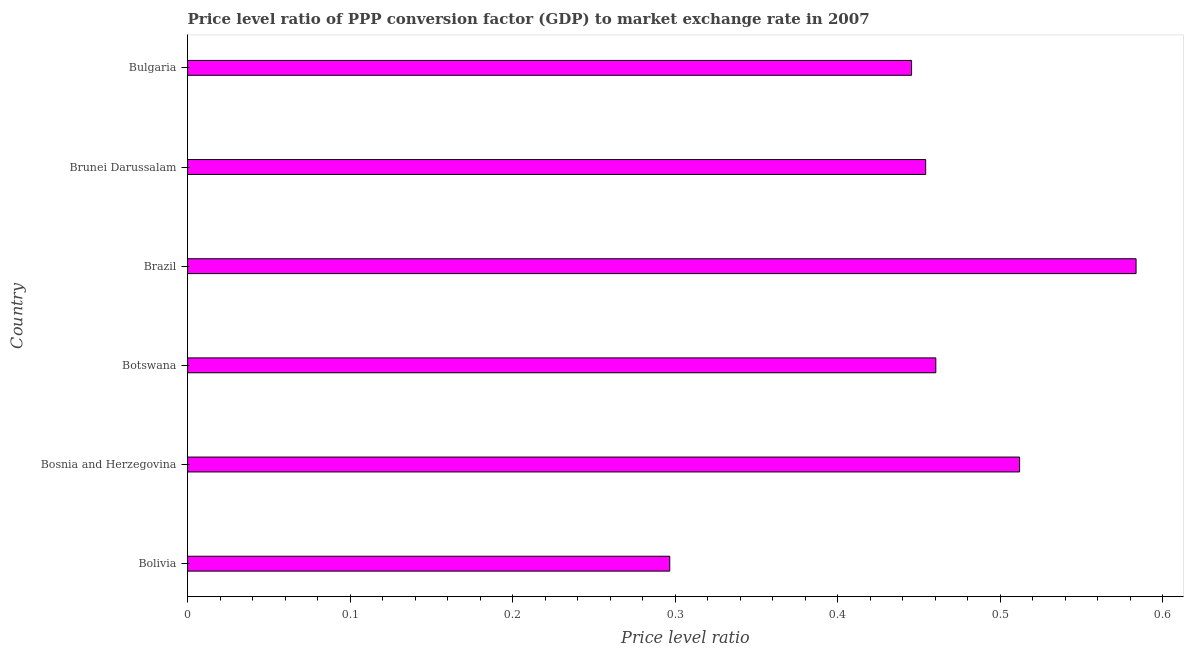What is the title of the graph?
Your answer should be compact. Price level ratio of PPP conversion factor (GDP) to market exchange rate in 2007. What is the label or title of the X-axis?
Ensure brevity in your answer.  Price level ratio. What is the price level ratio in Bosnia and Herzegovina?
Provide a short and direct response. 0.51. Across all countries, what is the maximum price level ratio?
Ensure brevity in your answer.  0.58. Across all countries, what is the minimum price level ratio?
Keep it short and to the point. 0.3. In which country was the price level ratio minimum?
Give a very brief answer. Bolivia. What is the sum of the price level ratio?
Give a very brief answer. 2.75. What is the difference between the price level ratio in Bolivia and Brazil?
Provide a short and direct response. -0.29. What is the average price level ratio per country?
Your response must be concise. 0.46. What is the median price level ratio?
Your answer should be compact. 0.46. In how many countries, is the price level ratio greater than 0.04 ?
Your answer should be very brief. 6. What is the ratio of the price level ratio in Bosnia and Herzegovina to that in Brunei Darussalam?
Your answer should be compact. 1.13. Is the price level ratio in Bosnia and Herzegovina less than that in Bulgaria?
Make the answer very short. No. What is the difference between the highest and the second highest price level ratio?
Your response must be concise. 0.07. Is the sum of the price level ratio in Bosnia and Herzegovina and Brunei Darussalam greater than the maximum price level ratio across all countries?
Provide a succinct answer. Yes. What is the difference between the highest and the lowest price level ratio?
Make the answer very short. 0.29. In how many countries, is the price level ratio greater than the average price level ratio taken over all countries?
Your answer should be very brief. 3. Are all the bars in the graph horizontal?
Offer a very short reply. Yes. Are the values on the major ticks of X-axis written in scientific E-notation?
Give a very brief answer. No. What is the Price level ratio in Bolivia?
Offer a terse response. 0.3. What is the Price level ratio of Bosnia and Herzegovina?
Make the answer very short. 0.51. What is the Price level ratio in Botswana?
Provide a succinct answer. 0.46. What is the Price level ratio of Brazil?
Offer a terse response. 0.58. What is the Price level ratio of Brunei Darussalam?
Your response must be concise. 0.45. What is the Price level ratio in Bulgaria?
Ensure brevity in your answer.  0.45. What is the difference between the Price level ratio in Bolivia and Bosnia and Herzegovina?
Offer a very short reply. -0.22. What is the difference between the Price level ratio in Bolivia and Botswana?
Provide a succinct answer. -0.16. What is the difference between the Price level ratio in Bolivia and Brazil?
Give a very brief answer. -0.29. What is the difference between the Price level ratio in Bolivia and Brunei Darussalam?
Ensure brevity in your answer.  -0.16. What is the difference between the Price level ratio in Bolivia and Bulgaria?
Give a very brief answer. -0.15. What is the difference between the Price level ratio in Bosnia and Herzegovina and Botswana?
Keep it short and to the point. 0.05. What is the difference between the Price level ratio in Bosnia and Herzegovina and Brazil?
Provide a succinct answer. -0.07. What is the difference between the Price level ratio in Bosnia and Herzegovina and Brunei Darussalam?
Ensure brevity in your answer.  0.06. What is the difference between the Price level ratio in Bosnia and Herzegovina and Bulgaria?
Your answer should be compact. 0.07. What is the difference between the Price level ratio in Botswana and Brazil?
Give a very brief answer. -0.12. What is the difference between the Price level ratio in Botswana and Brunei Darussalam?
Keep it short and to the point. 0.01. What is the difference between the Price level ratio in Botswana and Bulgaria?
Make the answer very short. 0.01. What is the difference between the Price level ratio in Brazil and Brunei Darussalam?
Provide a succinct answer. 0.13. What is the difference between the Price level ratio in Brazil and Bulgaria?
Ensure brevity in your answer.  0.14. What is the difference between the Price level ratio in Brunei Darussalam and Bulgaria?
Your answer should be compact. 0.01. What is the ratio of the Price level ratio in Bolivia to that in Bosnia and Herzegovina?
Make the answer very short. 0.58. What is the ratio of the Price level ratio in Bolivia to that in Botswana?
Provide a short and direct response. 0.64. What is the ratio of the Price level ratio in Bolivia to that in Brazil?
Provide a succinct answer. 0.51. What is the ratio of the Price level ratio in Bolivia to that in Brunei Darussalam?
Your answer should be very brief. 0.65. What is the ratio of the Price level ratio in Bolivia to that in Bulgaria?
Offer a terse response. 0.67. What is the ratio of the Price level ratio in Bosnia and Herzegovina to that in Botswana?
Give a very brief answer. 1.11. What is the ratio of the Price level ratio in Bosnia and Herzegovina to that in Brazil?
Provide a short and direct response. 0.88. What is the ratio of the Price level ratio in Bosnia and Herzegovina to that in Brunei Darussalam?
Offer a very short reply. 1.13. What is the ratio of the Price level ratio in Bosnia and Herzegovina to that in Bulgaria?
Offer a terse response. 1.15. What is the ratio of the Price level ratio in Botswana to that in Brazil?
Offer a very short reply. 0.79. What is the ratio of the Price level ratio in Botswana to that in Brunei Darussalam?
Provide a short and direct response. 1.01. What is the ratio of the Price level ratio in Botswana to that in Bulgaria?
Make the answer very short. 1.03. What is the ratio of the Price level ratio in Brazil to that in Brunei Darussalam?
Provide a succinct answer. 1.28. What is the ratio of the Price level ratio in Brazil to that in Bulgaria?
Keep it short and to the point. 1.31. 